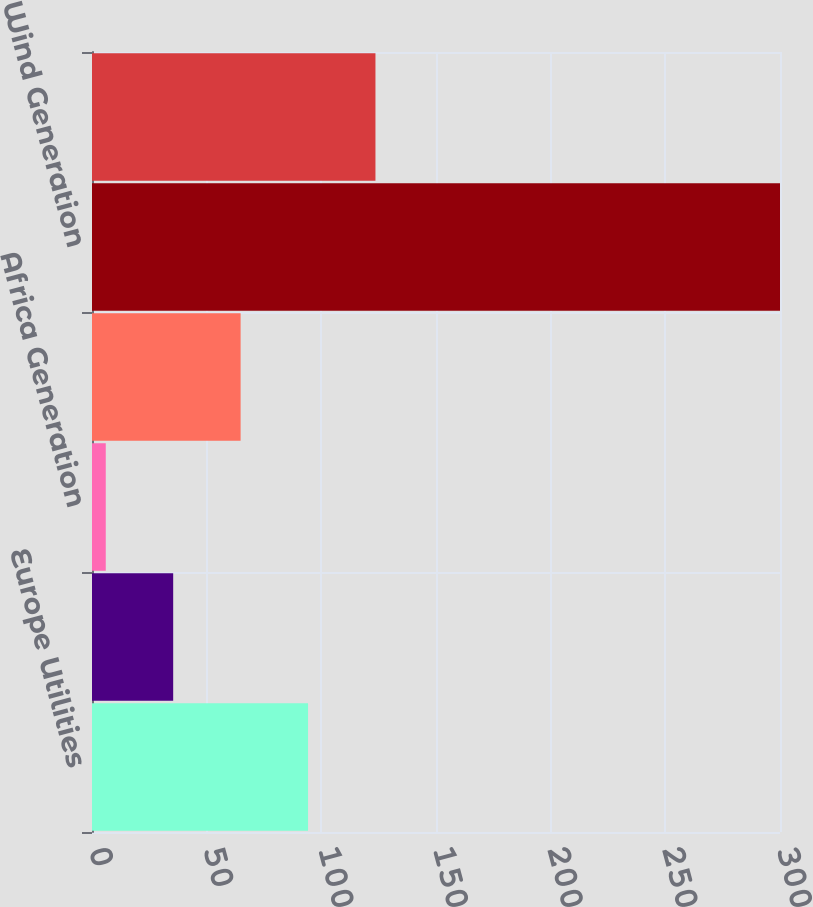<chart> <loc_0><loc_0><loc_500><loc_500><bar_chart><fcel>Europe Utilities<fcel>Africa Utilities<fcel>Africa Generation<fcel>Total Corporate and Other<fcel>Wind Generation<fcel>Corp/Other<nl><fcel>94.2<fcel>35.4<fcel>6<fcel>64.8<fcel>300<fcel>123.6<nl></chart> 